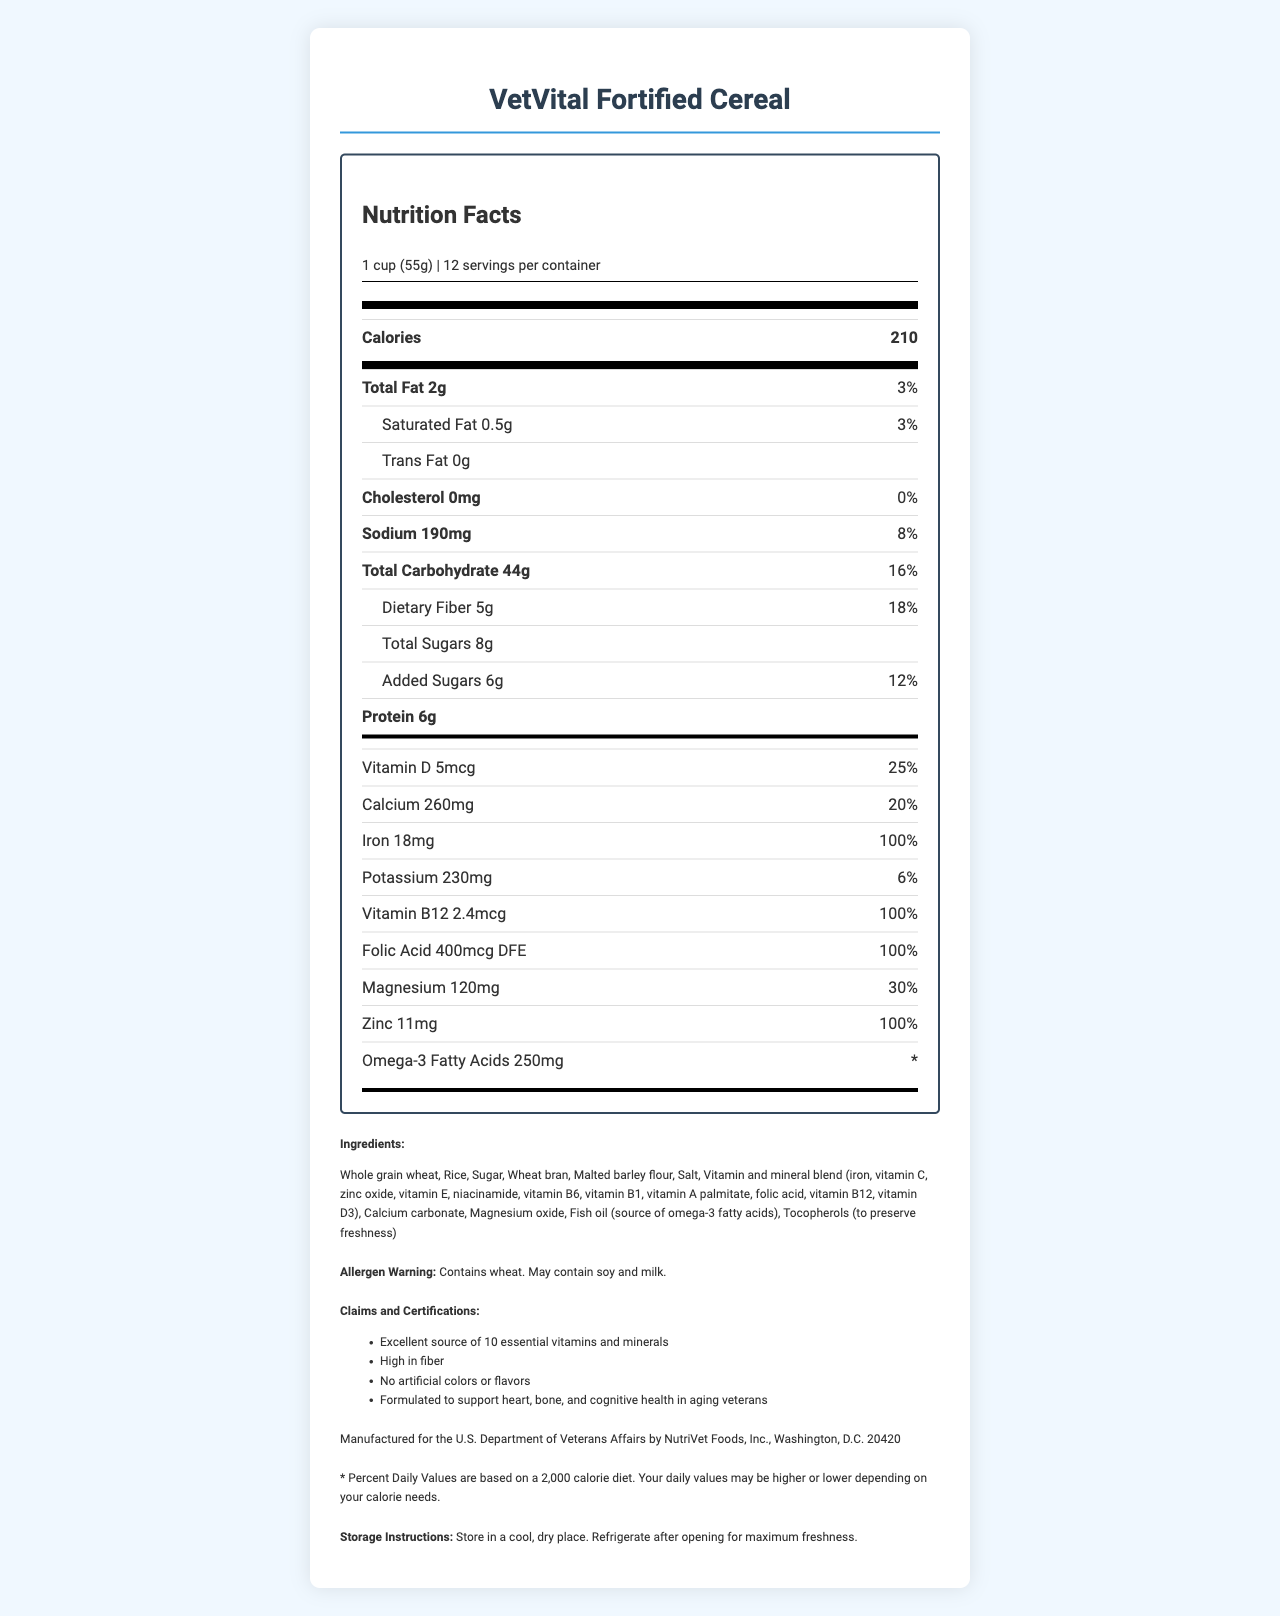what is the serving size of VetVital Fortified Cereal? The serving size is listed at the top of the Nutrition Facts label.
Answer: 1 cup (55g) how many servings are in one container? The document states "12 servings per container" under the serving size information.
Answer: 12 how many calories are in one serving? The calorie content per serving is displayed next to "Calories".
Answer: 210 what is the amount of protein per serving? The amount of protein per serving is shown as "Protein 6g".
Answer: 6g what percentage of daily iron does one serving provide? The daily value percentage for iron is listed as "100%" in the nutrients section.
Answer: 100% how much omega-3 fatty acids are in one serving? A. 100mg B. 150mg C. 200mg D. 250mg The document states that each serving contains 250mg of omega-3 fatty acids.
Answer: D. 250mg what is the percentage of daily value of saturated fat? A. 2% B. 3% C. 4% D. 5% The percentage of daily value for saturated fat is listed as "3%" in the sub-nutrient section under Total Fat.
Answer: B. 3% is VetVital Fortified Cereal free from cholesterol? The label shows "Cholesterol 0mg," indicating that it is cholesterol-free.
Answer: Yes summarize the nutritional claims and certifications of VetVital Fortified Cereal. The claims and certifications listed emphasize its nutritional benefits, lack of artificial ingredients, and its specialized formulation for aging veterans’ health.
Answer: Excellent source of 10 essential vitamins and minerals, High in fiber, No artificial colors or flavors, Formulated to support heart, bone, and cognitive health in aging veterans is there wheat in the ingredients of VetVital Fortified Cereal? The allergen warning explicitly mentions "Contains wheat".
Answer: Yes what is the source of omega-3 fatty acids in this cereal? In the ingredients list, fish oil is specified as the source of omega-3 fatty acids.
Answer: Fish oil what is the main ingredient in VetVital Fortified Cereal? The first ingredient listed is "Whole grain wheat," indicating it is the main ingredient.
Answer: Whole grain wheat can you determine the price of VetVital Fortified Cereal from the document? The document does not provide any information about the price of the cereal.
Answer: Cannot be determined what organization is VetVital Fortified Cereal manufactured for? The manufacturer information states it is for the U.S. Department of Veterans Affairs.
Answer: U.S. Department of Veterans Affairs where should VetVital Fortified Cereal be stored after opening? The storage instructions indicate that the cereal should be refrigerated after opening for maximum freshness.
Answer: Refrigerate for maximum freshness 